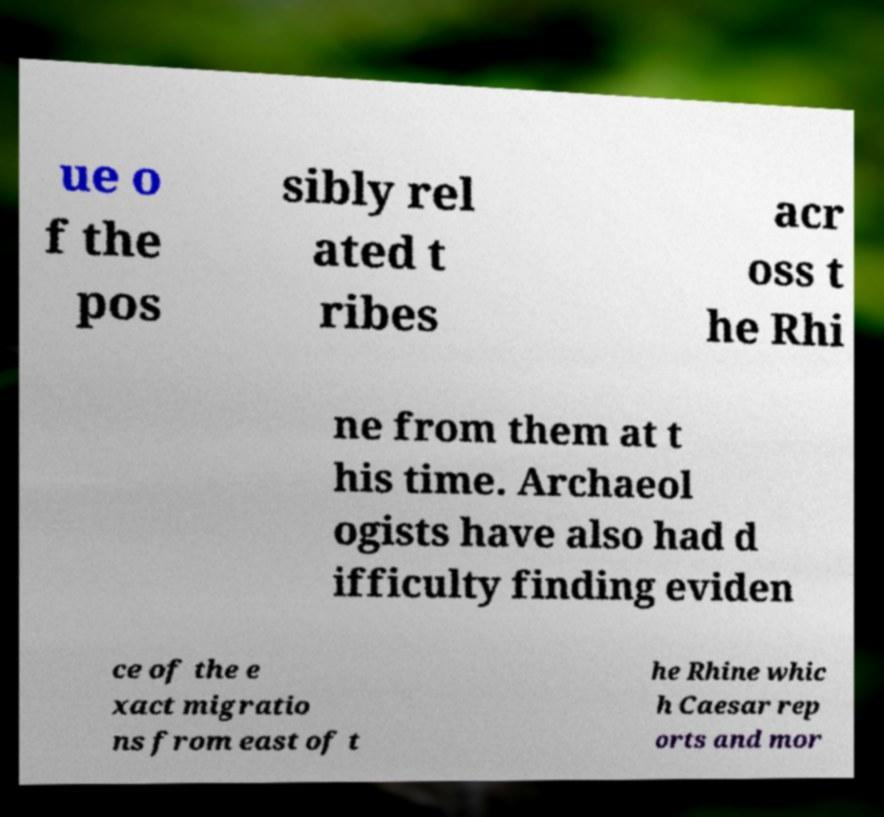Could you assist in decoding the text presented in this image and type it out clearly? ue o f the pos sibly rel ated t ribes acr oss t he Rhi ne from them at t his time. Archaeol ogists have also had d ifficulty finding eviden ce of the e xact migratio ns from east of t he Rhine whic h Caesar rep orts and mor 